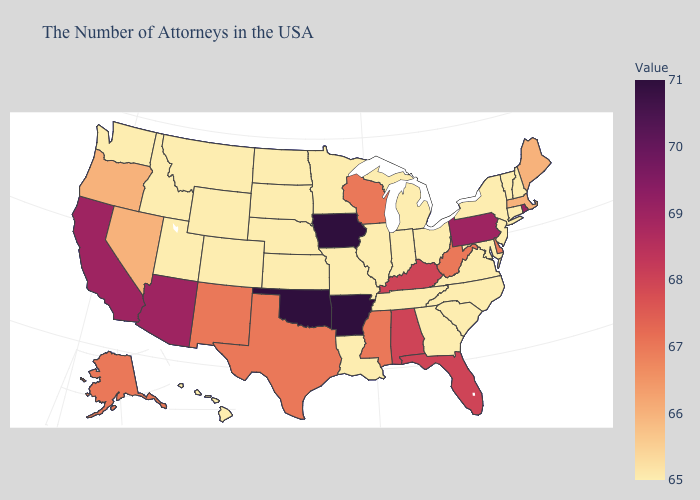Does Oklahoma have a higher value than Rhode Island?
Concise answer only. Yes. Which states have the highest value in the USA?
Give a very brief answer. Arkansas, Iowa, Oklahoma. Does the map have missing data?
Give a very brief answer. No. Does Louisiana have the lowest value in the South?
Concise answer only. Yes. Does Rhode Island have the highest value in the Northeast?
Be succinct. Yes. Which states have the highest value in the USA?
Answer briefly. Arkansas, Iowa, Oklahoma. 